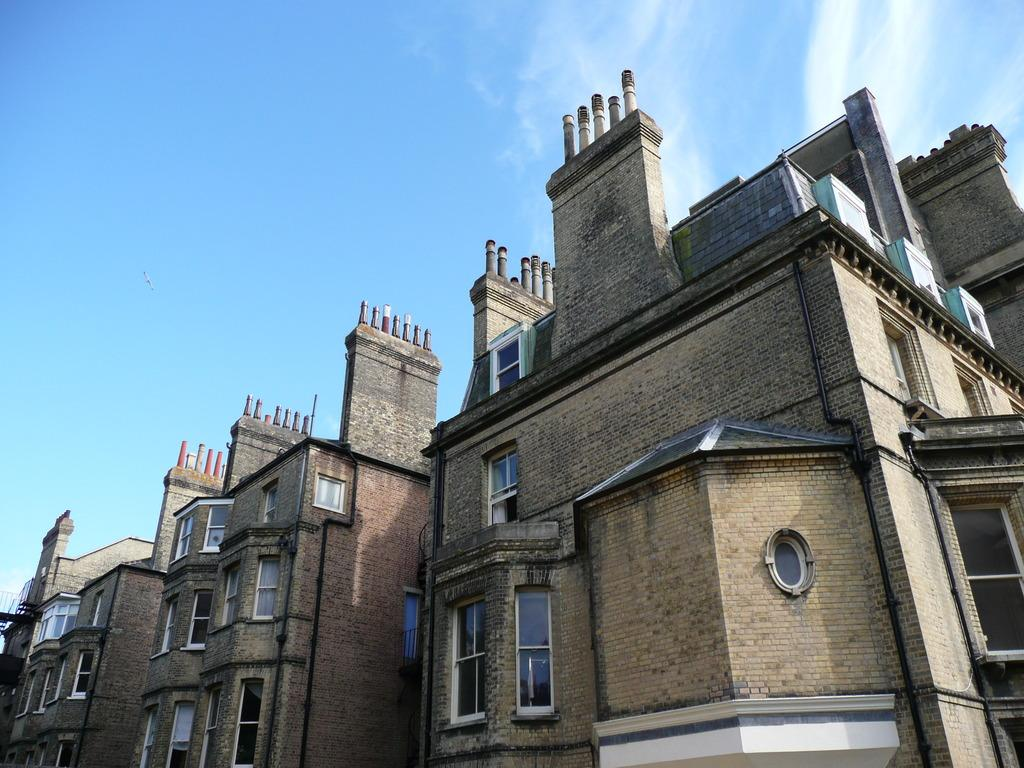What is the main subject in the center of the image? There are buildings in the center of the image. What can be seen at the top of the image? The sky is visible at the top of the image. How many cats are sitting on the roof of the building in the image? There are no cats present in the image; it only features buildings and the sky. 